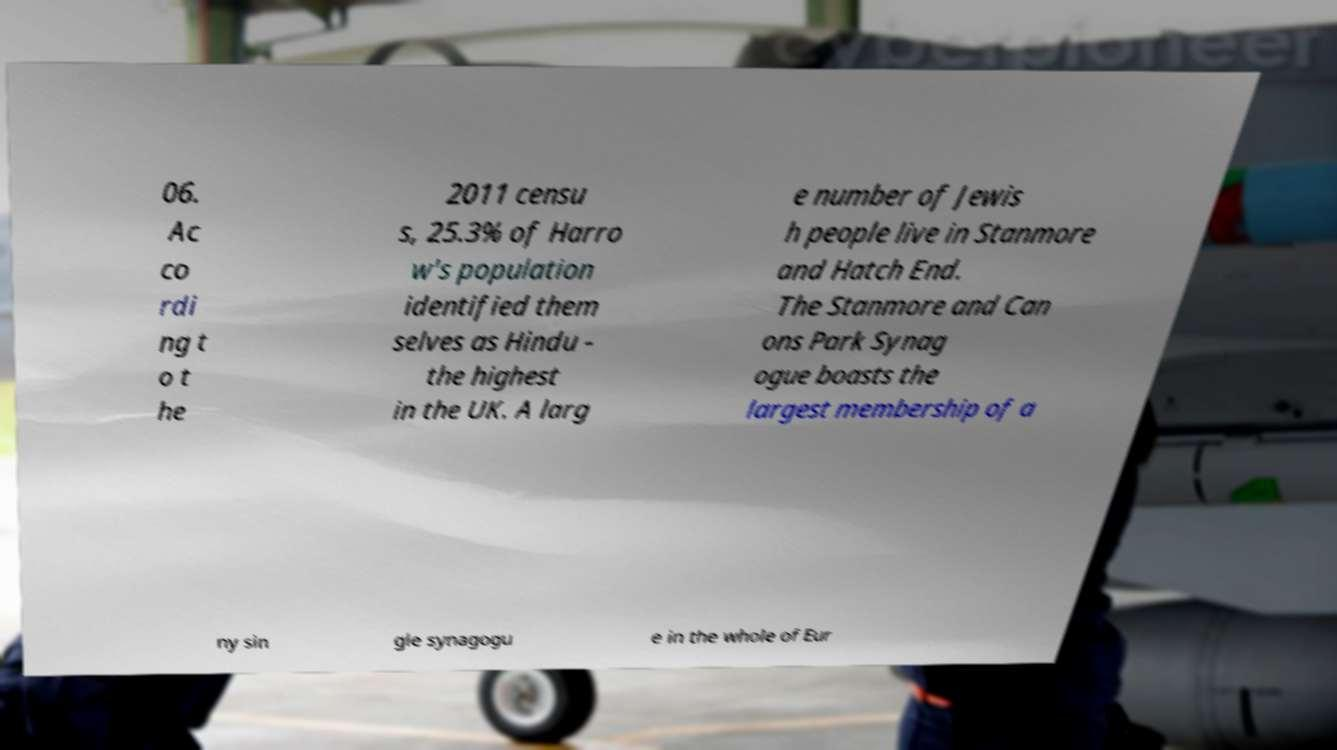I need the written content from this picture converted into text. Can you do that? 06. Ac co rdi ng t o t he 2011 censu s, 25.3% of Harro w's population identified them selves as Hindu - the highest in the UK. A larg e number of Jewis h people live in Stanmore and Hatch End. The Stanmore and Can ons Park Synag ogue boasts the largest membership of a ny sin gle synagogu e in the whole of Eur 